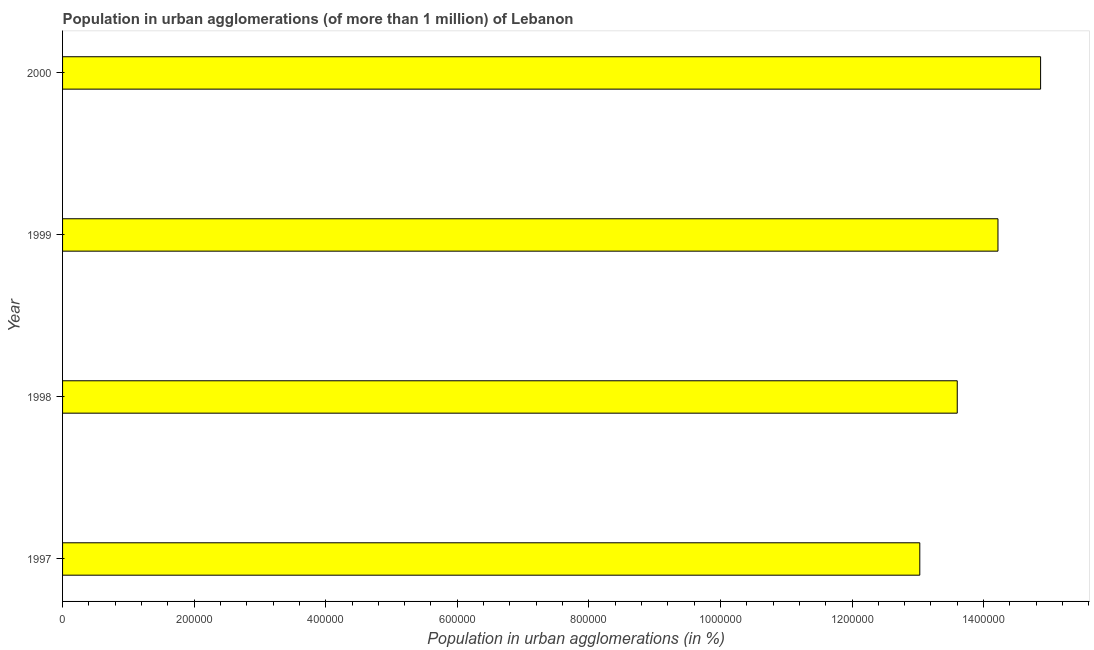Does the graph contain grids?
Provide a succinct answer. No. What is the title of the graph?
Your response must be concise. Population in urban agglomerations (of more than 1 million) of Lebanon. What is the label or title of the X-axis?
Make the answer very short. Population in urban agglomerations (in %). What is the population in urban agglomerations in 1997?
Offer a very short reply. 1.30e+06. Across all years, what is the maximum population in urban agglomerations?
Your answer should be compact. 1.49e+06. Across all years, what is the minimum population in urban agglomerations?
Offer a very short reply. 1.30e+06. In which year was the population in urban agglomerations maximum?
Offer a terse response. 2000. In which year was the population in urban agglomerations minimum?
Your answer should be compact. 1997. What is the sum of the population in urban agglomerations?
Provide a succinct answer. 5.57e+06. What is the difference between the population in urban agglomerations in 1997 and 2000?
Keep it short and to the point. -1.84e+05. What is the average population in urban agglomerations per year?
Provide a short and direct response. 1.39e+06. What is the median population in urban agglomerations?
Give a very brief answer. 1.39e+06. What is the ratio of the population in urban agglomerations in 1998 to that in 1999?
Your answer should be compact. 0.96. Is the difference between the population in urban agglomerations in 1997 and 2000 greater than the difference between any two years?
Keep it short and to the point. Yes. What is the difference between the highest and the second highest population in urban agglomerations?
Your answer should be very brief. 6.48e+04. Is the sum of the population in urban agglomerations in 1997 and 1998 greater than the maximum population in urban agglomerations across all years?
Your answer should be compact. Yes. What is the difference between the highest and the lowest population in urban agglomerations?
Make the answer very short. 1.84e+05. In how many years, is the population in urban agglomerations greater than the average population in urban agglomerations taken over all years?
Your answer should be very brief. 2. How many bars are there?
Make the answer very short. 4. Are all the bars in the graph horizontal?
Keep it short and to the point. Yes. How many years are there in the graph?
Offer a terse response. 4. What is the difference between two consecutive major ticks on the X-axis?
Your response must be concise. 2.00e+05. Are the values on the major ticks of X-axis written in scientific E-notation?
Your answer should be very brief. No. What is the Population in urban agglomerations (in %) of 1997?
Your answer should be very brief. 1.30e+06. What is the Population in urban agglomerations (in %) in 1998?
Make the answer very short. 1.36e+06. What is the Population in urban agglomerations (in %) in 1999?
Keep it short and to the point. 1.42e+06. What is the Population in urban agglomerations (in %) of 2000?
Make the answer very short. 1.49e+06. What is the difference between the Population in urban agglomerations (in %) in 1997 and 1998?
Offer a terse response. -5.69e+04. What is the difference between the Population in urban agglomerations (in %) in 1997 and 1999?
Your answer should be compact. -1.19e+05. What is the difference between the Population in urban agglomerations (in %) in 1997 and 2000?
Offer a very short reply. -1.84e+05. What is the difference between the Population in urban agglomerations (in %) in 1998 and 1999?
Provide a succinct answer. -6.19e+04. What is the difference between the Population in urban agglomerations (in %) in 1998 and 2000?
Provide a succinct answer. -1.27e+05. What is the difference between the Population in urban agglomerations (in %) in 1999 and 2000?
Offer a very short reply. -6.48e+04. What is the ratio of the Population in urban agglomerations (in %) in 1997 to that in 1998?
Your answer should be compact. 0.96. What is the ratio of the Population in urban agglomerations (in %) in 1997 to that in 1999?
Provide a succinct answer. 0.92. What is the ratio of the Population in urban agglomerations (in %) in 1997 to that in 2000?
Provide a succinct answer. 0.88. What is the ratio of the Population in urban agglomerations (in %) in 1998 to that in 1999?
Your answer should be very brief. 0.96. What is the ratio of the Population in urban agglomerations (in %) in 1998 to that in 2000?
Your response must be concise. 0.92. What is the ratio of the Population in urban agglomerations (in %) in 1999 to that in 2000?
Provide a short and direct response. 0.96. 